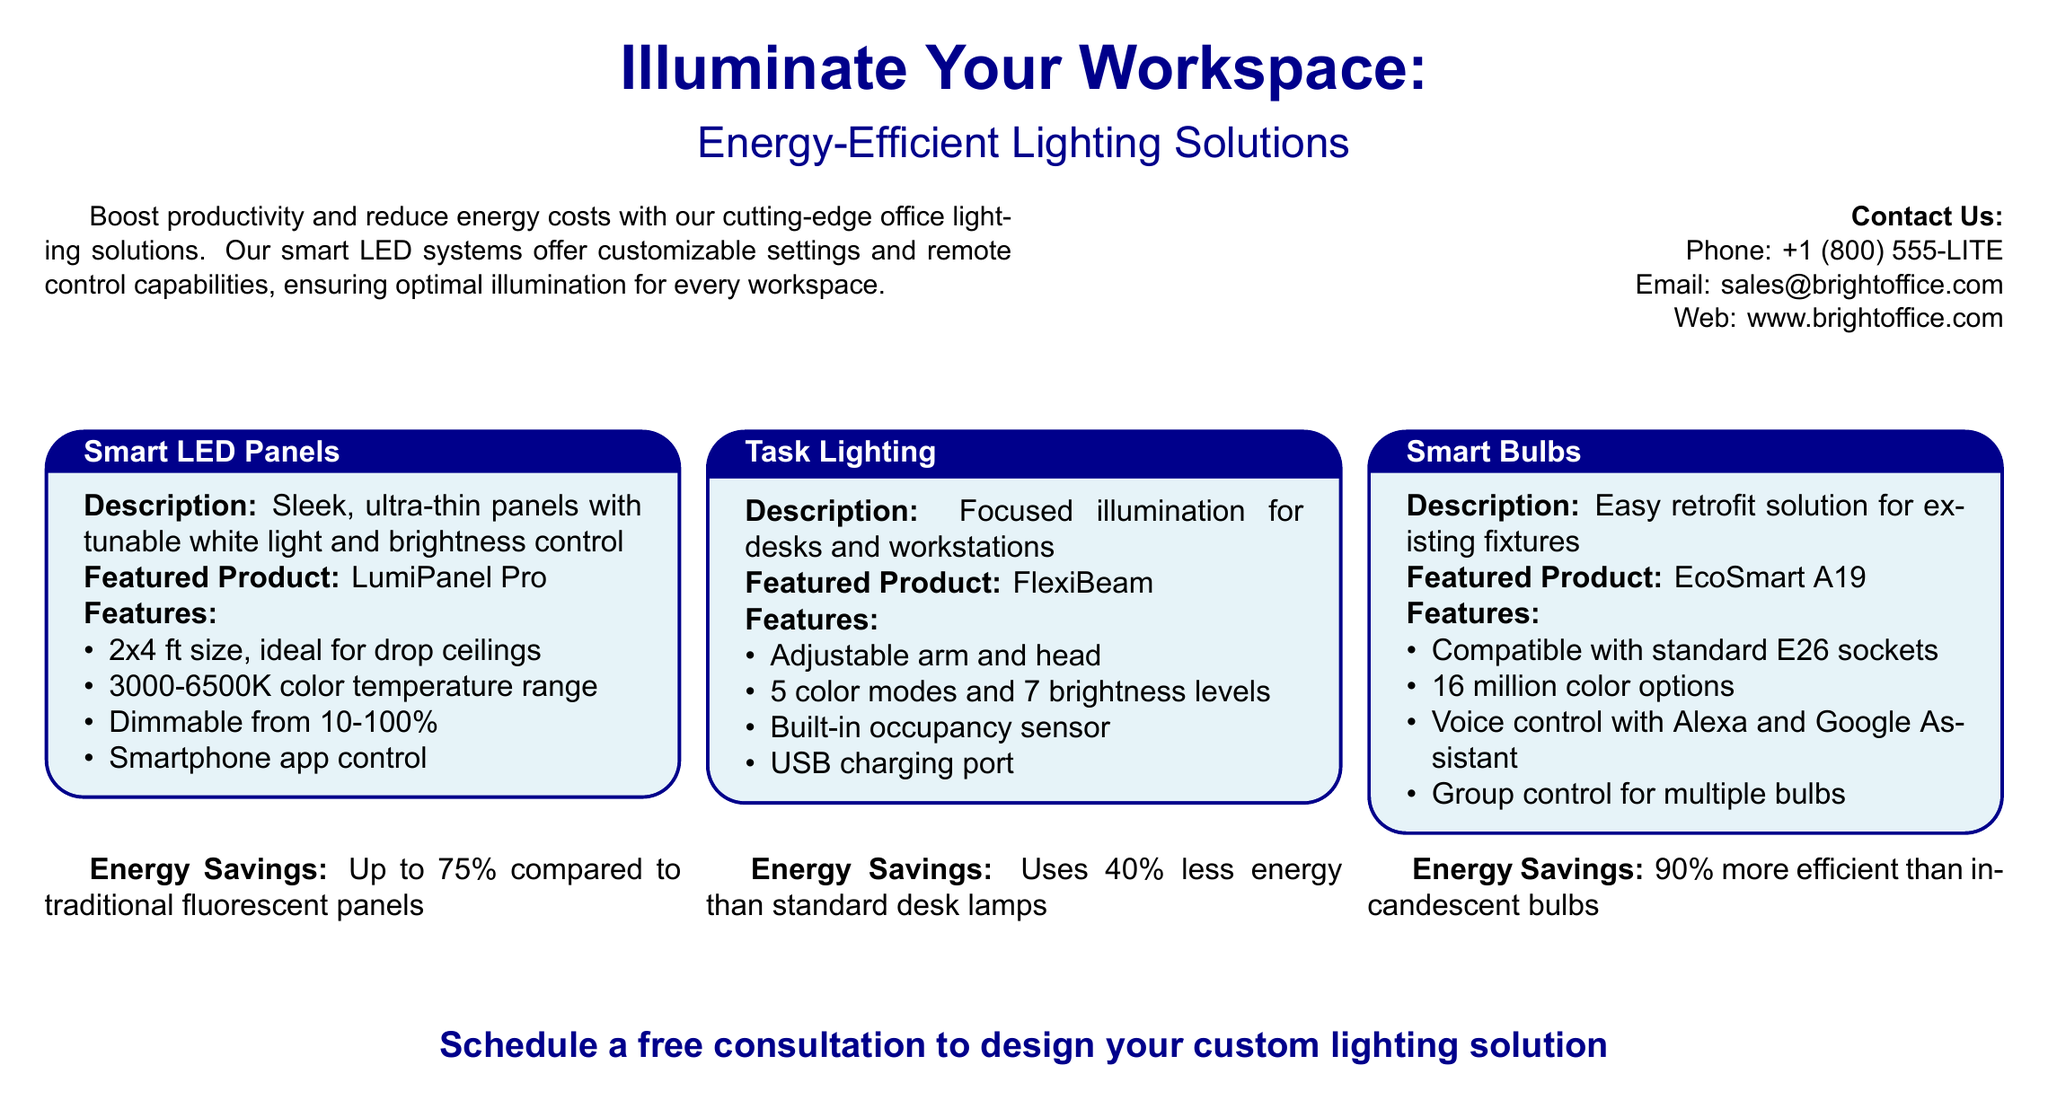What is the color temperature range of the LumiPanel Pro? The color temperature range of the LumiPanel Pro is specified as 3000-6500K in the document.
Answer: 3000-6500K What type of control does the EcoSmart A19 smart bulb support? The EcoSmart A19 smart bulb supports voice control with Alexa and Google Assistant, as mentioned in the features.
Answer: Voice control How much energy savings does the FlexiBeam task light provide compared to standard desk lamps? The document states that the FlexiBeam uses 40% less energy than standard desk lamps, which is a feature highlighted.
Answer: 40% What is the phone number for sales inquiries? The phone number for sales inquiries is listed in the contact section of the document as +1 (800) 555-LITE.
Answer: +1 (800) 555-LITE How does the LumiPanel Pro connect for control? The document mentions smartphone app control as the connection method for the LumiPanel Pro.
Answer: Smartphone app control What is the size of the Smart LED Panels? The document specifies the size of the Smart LED Panels as 2x4 ft, making them ideal for drop ceilings.
Answer: 2x4 ft What is featured in the task lighting product? The featured product for task lighting is mentioned as FlexiBeam in the document.
Answer: FlexiBeam How many color modes does the FlexiBeam offer? The document indicates that the FlexiBeam offers 5 color modes for lighting preferences.
Answer: 5 color modes What is the energy savings of the Smart Bulbs compared to incandescent bulbs? The document states that Smart Bulbs are 90% more efficient than incandescent bulbs, reflecting their energy savings.
Answer: 90% 